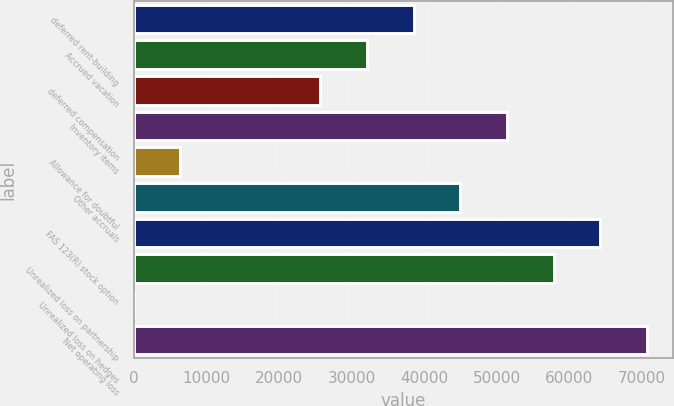Convert chart to OTSL. <chart><loc_0><loc_0><loc_500><loc_500><bar_chart><fcel>deferred rent-building<fcel>Accrued vacation<fcel>deferred compensation<fcel>Inventory items<fcel>Allowance for doubtful<fcel>Other accruals<fcel>FAS 123(R) stock option<fcel>Unrealized loss on partnership<fcel>Unrealized loss on hedges<fcel>Net operating loss<nl><fcel>38565<fcel>32139.5<fcel>25714<fcel>51416<fcel>6437.5<fcel>44990.5<fcel>64267<fcel>57841.5<fcel>12<fcel>70692.5<nl></chart> 